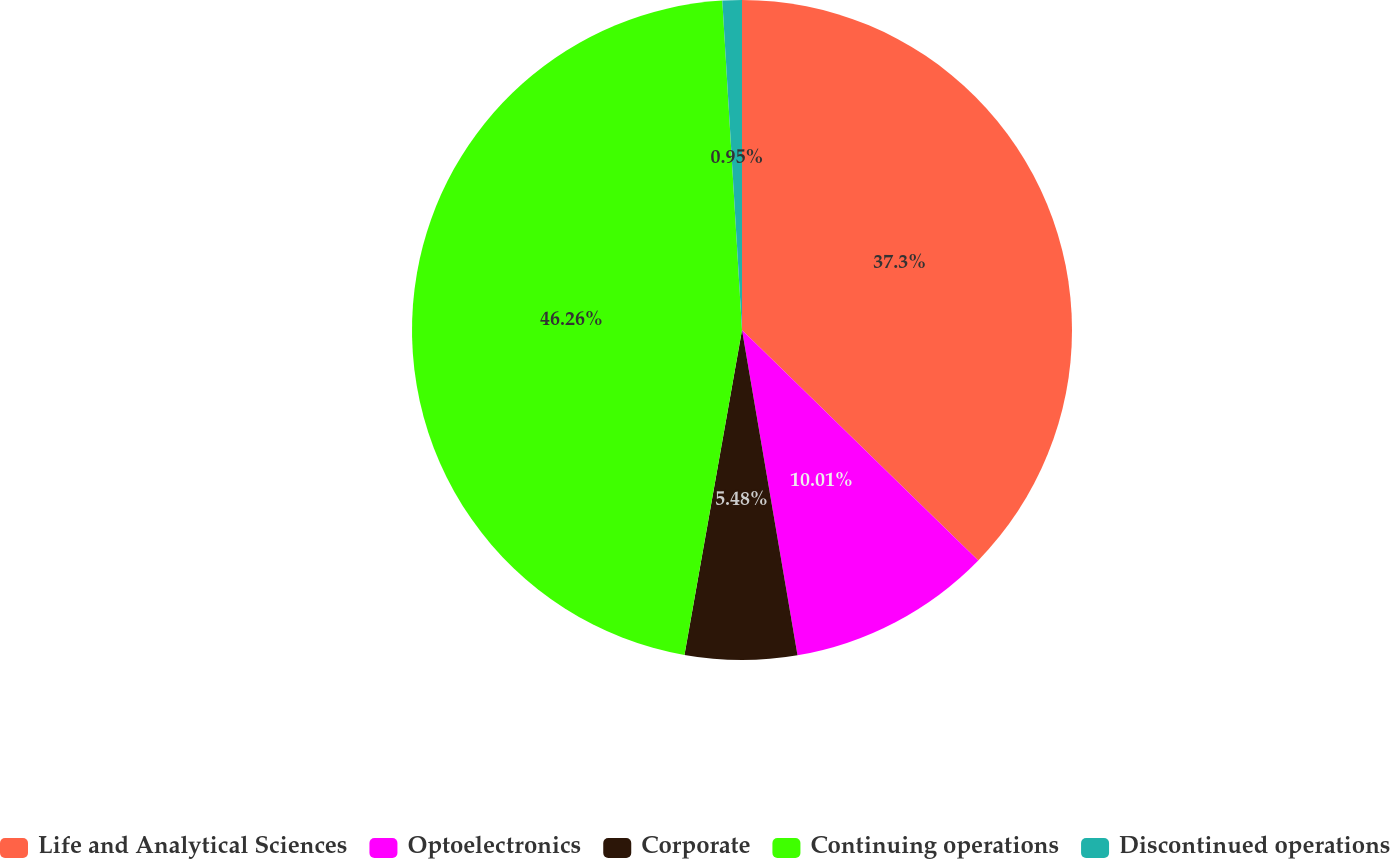<chart> <loc_0><loc_0><loc_500><loc_500><pie_chart><fcel>Life and Analytical Sciences<fcel>Optoelectronics<fcel>Corporate<fcel>Continuing operations<fcel>Discontinued operations<nl><fcel>37.3%<fcel>10.01%<fcel>5.48%<fcel>46.26%<fcel>0.95%<nl></chart> 